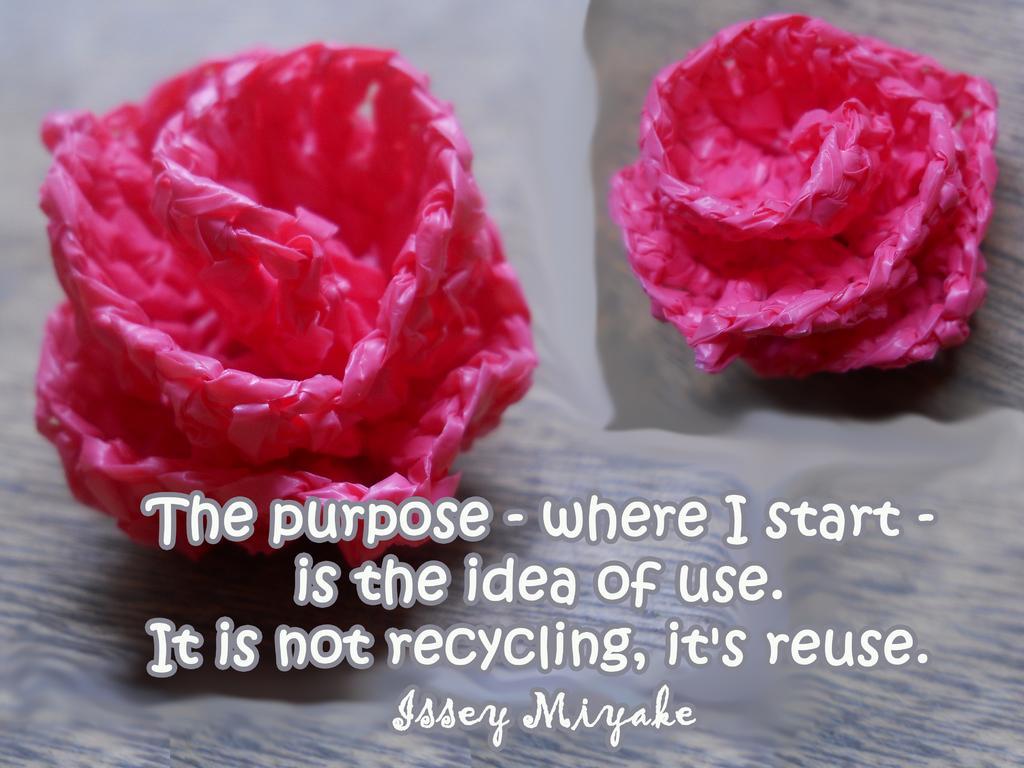Please provide a concise description of this image. In this picture there is a poster. On the both-sides we can see the plastic made flowers on the table. At the bottom there is a watermark. 